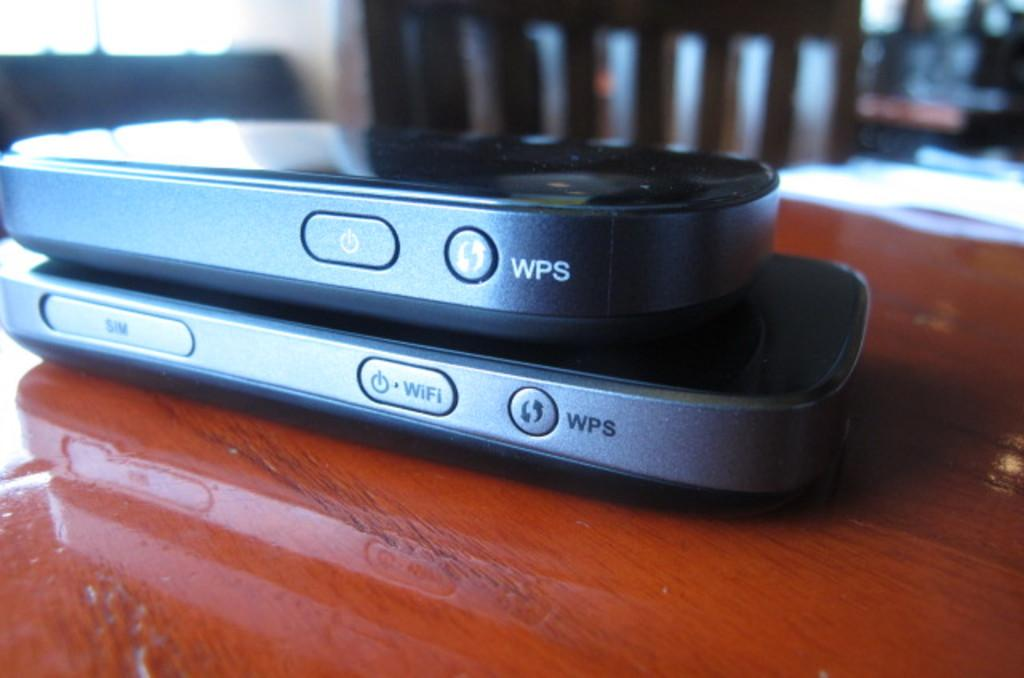Provide a one-sentence caption for the provided image. small electronic devices labeled with the word 'wps' on both. 